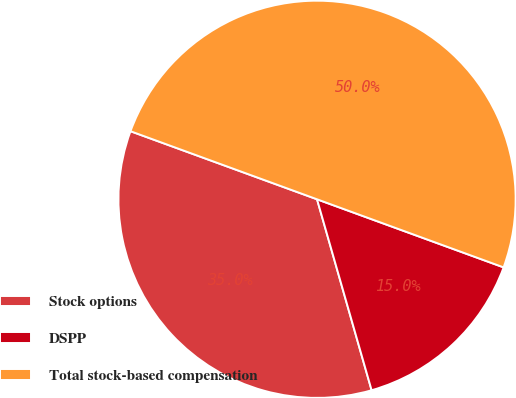<chart> <loc_0><loc_0><loc_500><loc_500><pie_chart><fcel>Stock options<fcel>DSPP<fcel>Total stock-based compensation<nl><fcel>35.0%<fcel>15.0%<fcel>50.0%<nl></chart> 